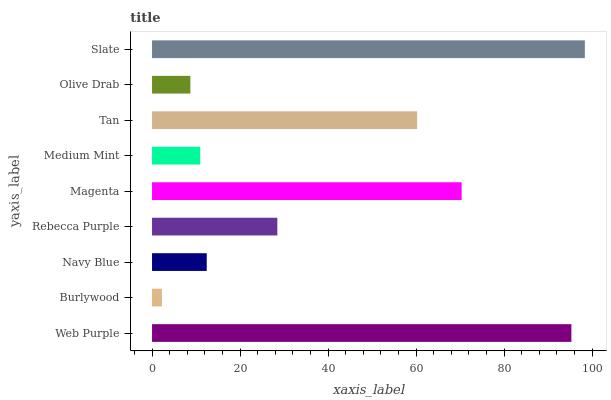Is Burlywood the minimum?
Answer yes or no. Yes. Is Slate the maximum?
Answer yes or no. Yes. Is Navy Blue the minimum?
Answer yes or no. No. Is Navy Blue the maximum?
Answer yes or no. No. Is Navy Blue greater than Burlywood?
Answer yes or no. Yes. Is Burlywood less than Navy Blue?
Answer yes or no. Yes. Is Burlywood greater than Navy Blue?
Answer yes or no. No. Is Navy Blue less than Burlywood?
Answer yes or no. No. Is Rebecca Purple the high median?
Answer yes or no. Yes. Is Rebecca Purple the low median?
Answer yes or no. Yes. Is Slate the high median?
Answer yes or no. No. Is Slate the low median?
Answer yes or no. No. 